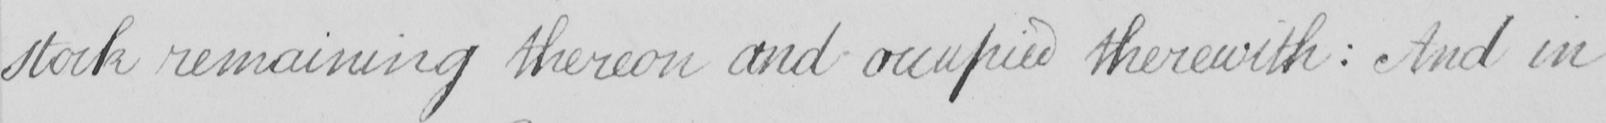Transcribe the text shown in this historical manuscript line. stock remaining thereon and occupied therewith  :  And in 